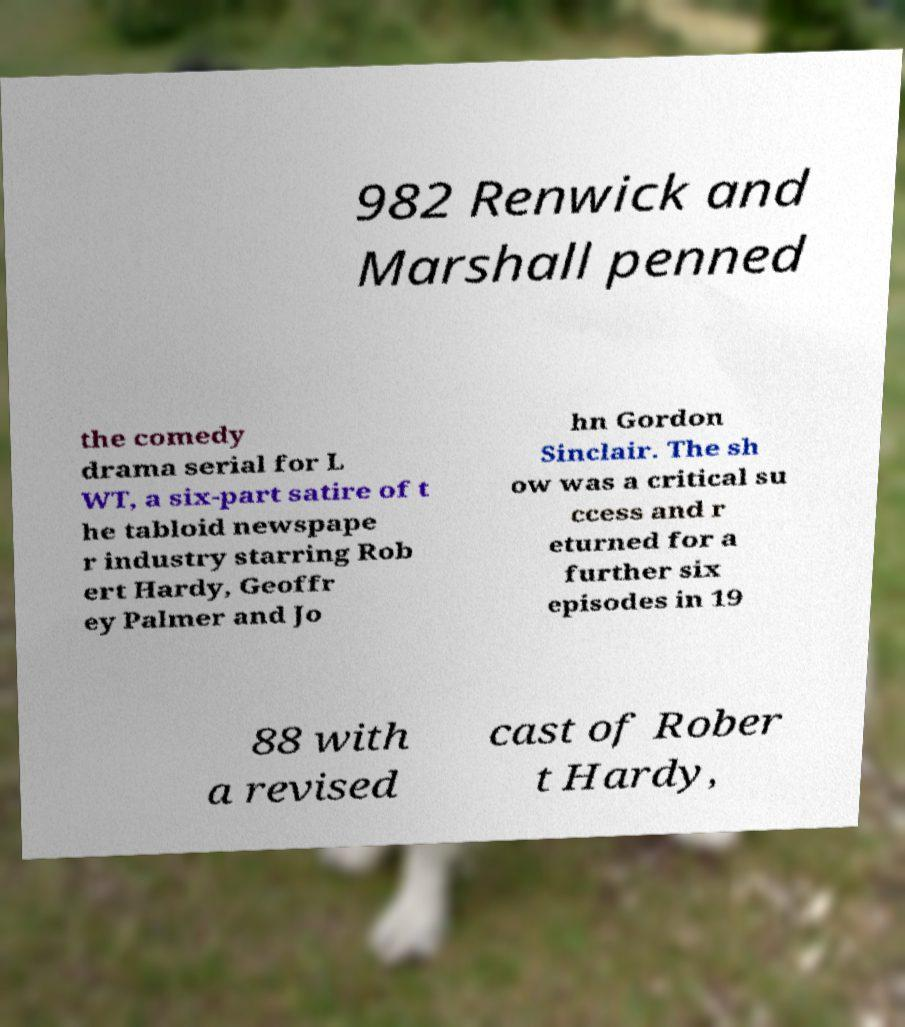Can you accurately transcribe the text from the provided image for me? 982 Renwick and Marshall penned the comedy drama serial for L WT, a six-part satire of t he tabloid newspape r industry starring Rob ert Hardy, Geoffr ey Palmer and Jo hn Gordon Sinclair. The sh ow was a critical su ccess and r eturned for a further six episodes in 19 88 with a revised cast of Rober t Hardy, 